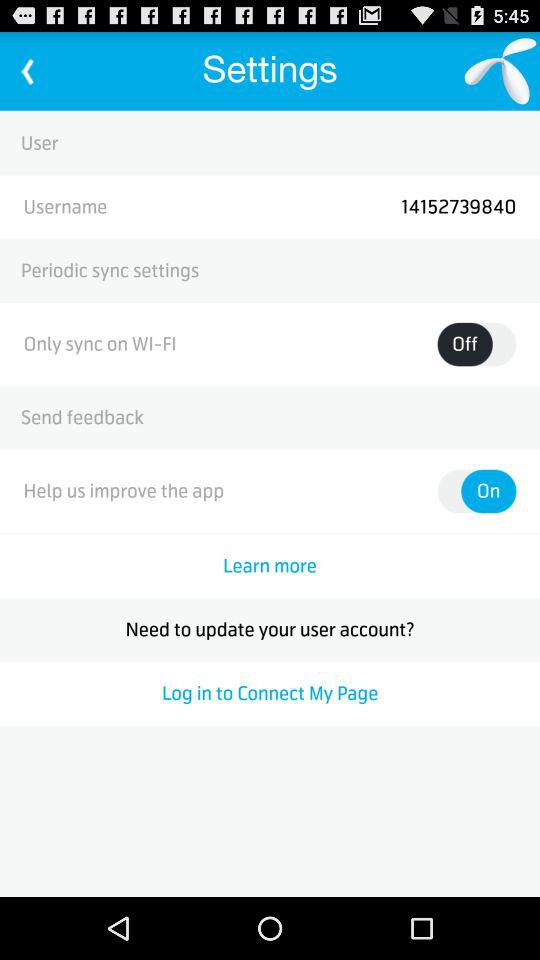What is the name of the synced Wi-Fi?
When the provided information is insufficient, respond with <no answer>. <no answer> 